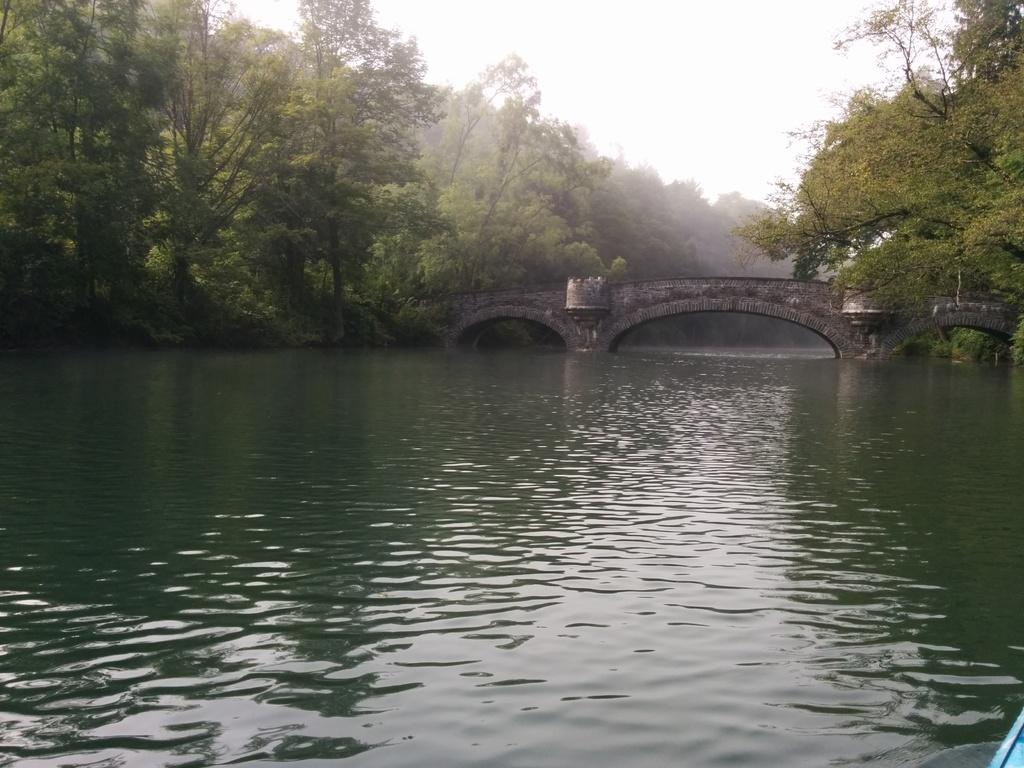What type of natural feature is visible in the image? There is a river in the image. How is the river interacting with the bridge in the image? The river is flowing under a bridge in the image. What architectural feature is present on the bridge? The bridge has a tunnel in the image. What type of vegetation can be seen in the image? Trees are present in the image. What type of chalk is being used to draw on the scene in the image? There is no chalk or drawing activity present in the image. What type of alley can be seen in the image? There is no alley present in the image; it features a river, a bridge, and trees. 